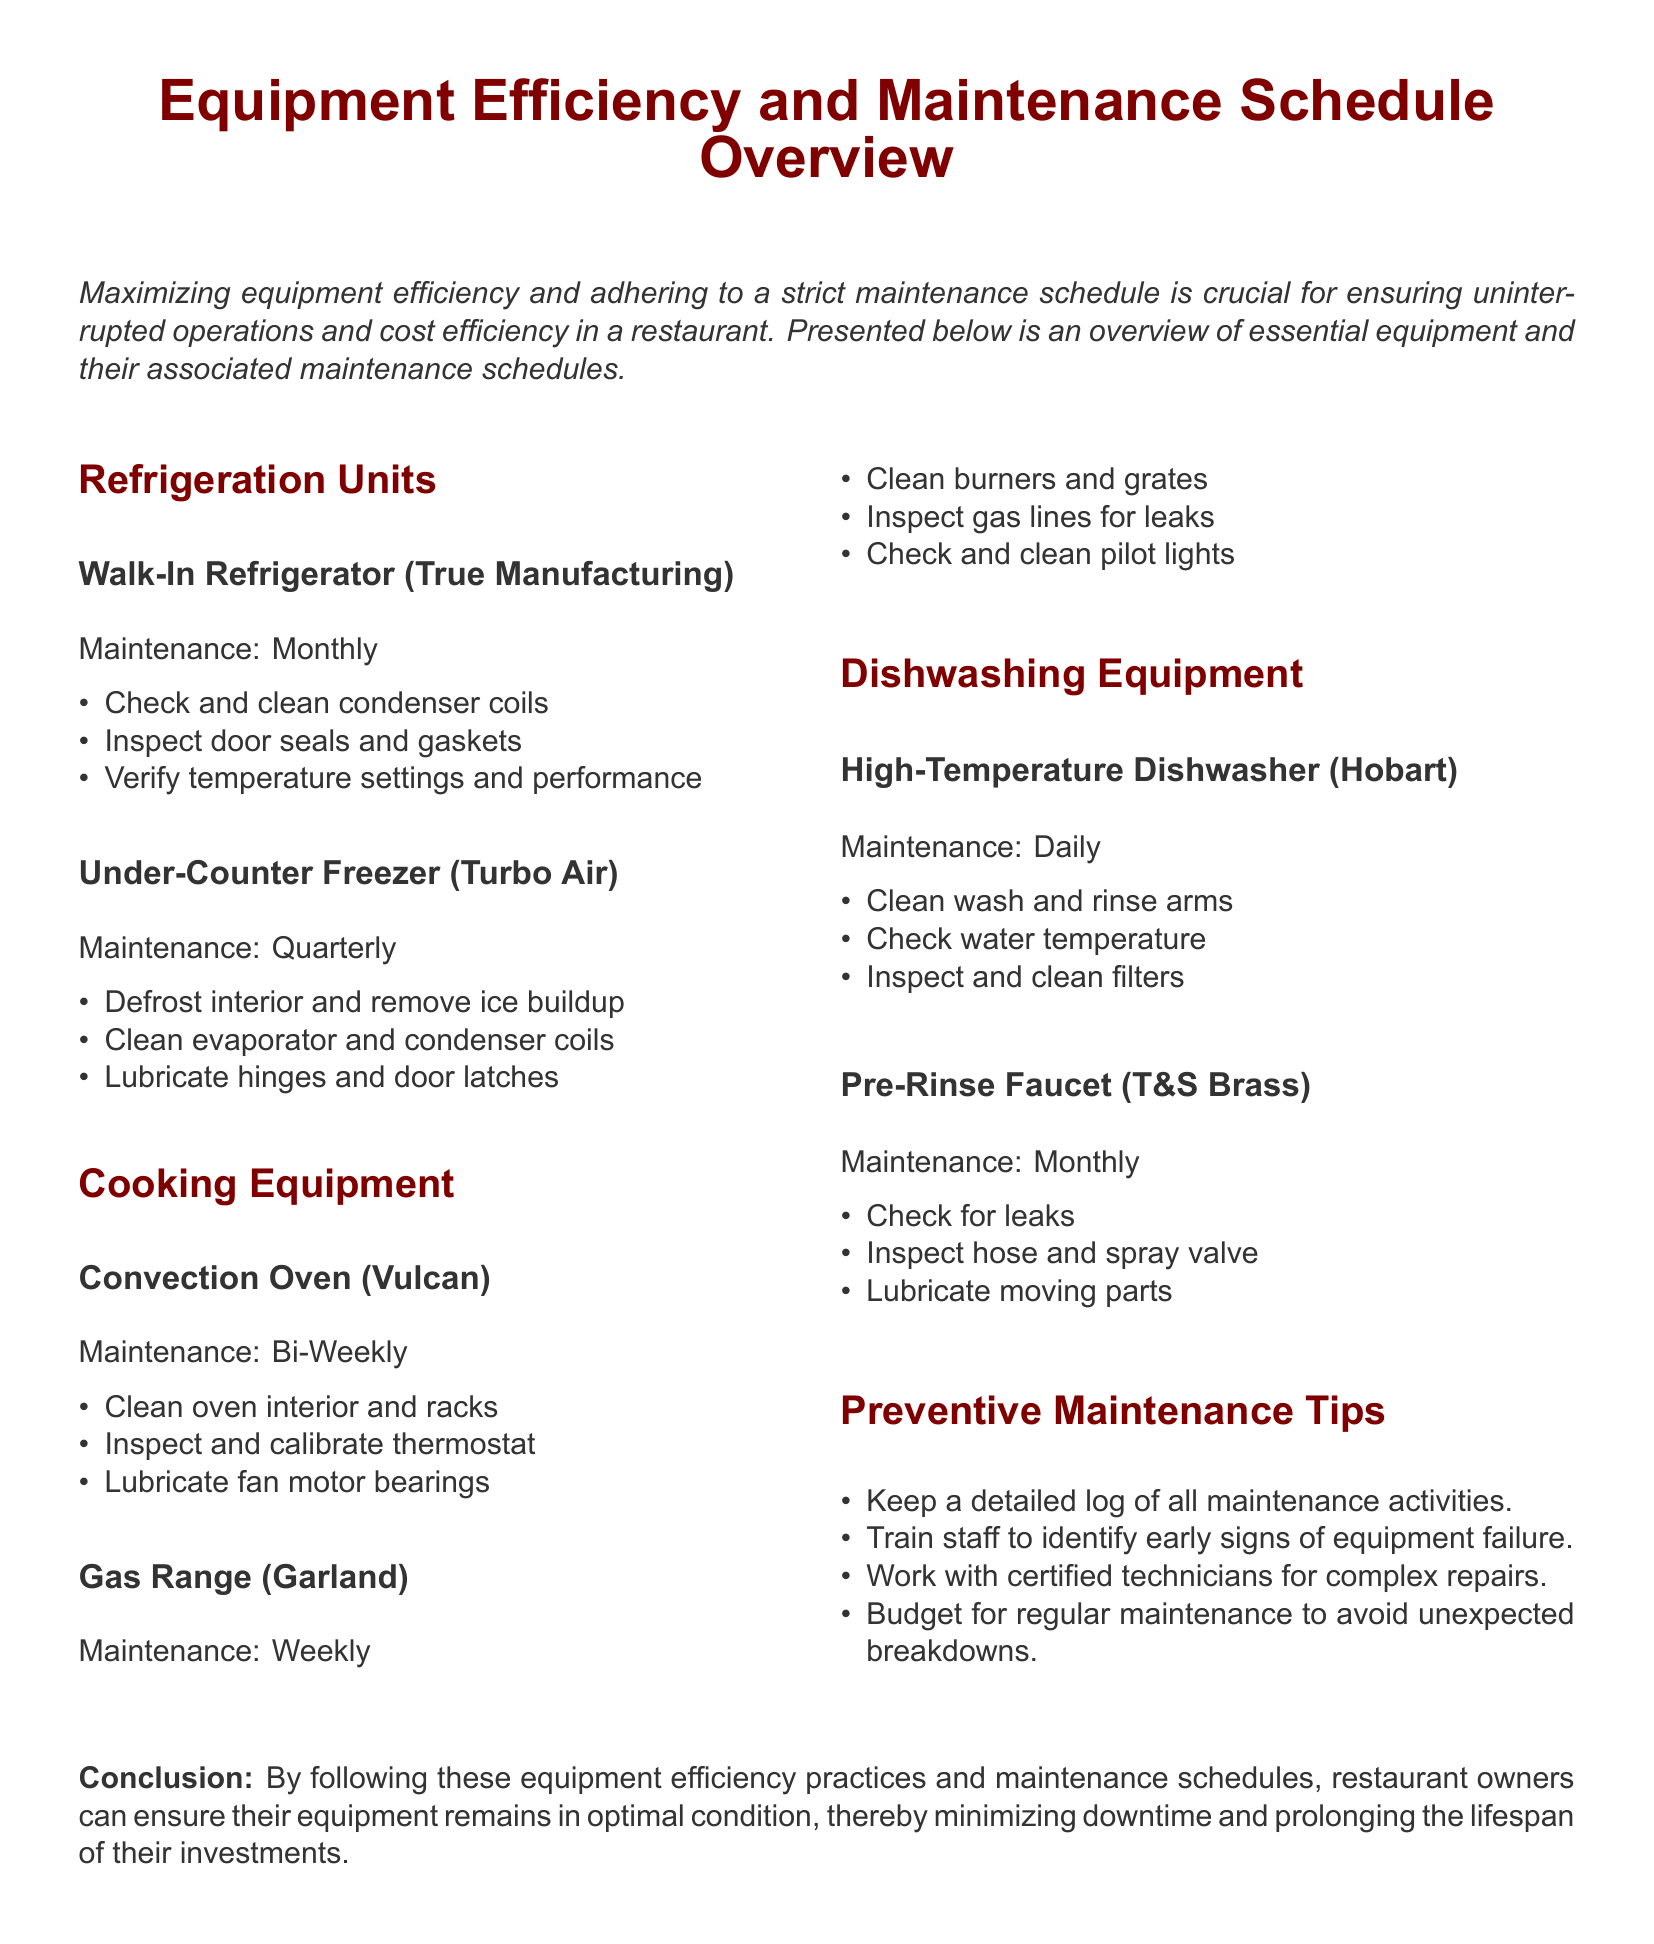what is the maintenance frequency for the Walk-In Refrigerator? The document specifies that the maintenance for the Walk-In Refrigerator is monthly.
Answer: Monthly how often should the Gas Range be maintained? According to the document, the Gas Range should be maintained weekly.
Answer: Weekly what is the main purpose of the document? The document highlights maximizing equipment efficiency and maintaining a strict maintenance schedule for restaurants.
Answer: Maximizing equipment efficiency how many types of cooking equipment are listed? There are two types of cooking equipment mentioned in the document: Convection Oven and Gas Range.
Answer: Two what monthly maintenance task is required for the Pre-Rinse Faucet? The document states that the Pre-Rinse Faucet maintenance includes checking for leaks.
Answer: Check for leaks which equipment requires daily maintenance? The High-Temperature Dishwasher is noted to require daily maintenance in the document.
Answer: High-Temperature Dishwasher what is advised to keep a log of? The document suggests keeping a detailed log of all maintenance activities.
Answer: Maintenance activities what should be lubricated for the Under-Counter Freezer? According to the document, the hinges and door latches of the Under-Counter Freezer should be lubricated.
Answer: Hinges and door latches how often does the Convection Oven require maintenance? The maintenance frequency for the Convection Oven is bi-weekly as stated in the document.
Answer: Bi-Weekly 